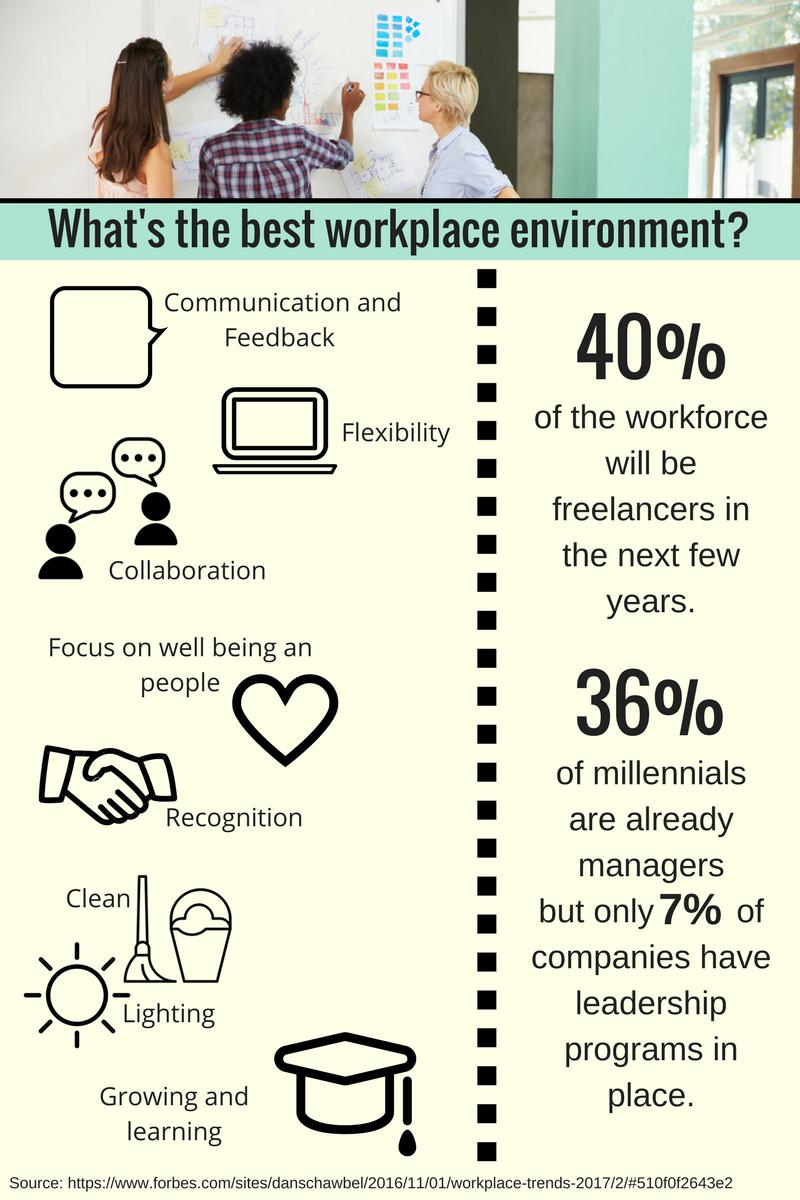List a handful of essential elements in this visual. This infographic mentions eight qualities of a workplace. According to a recent survey, 60% of millennials are not managers. According to a recent study, a staggering 93% of companies do not have any leadership programs in place. 